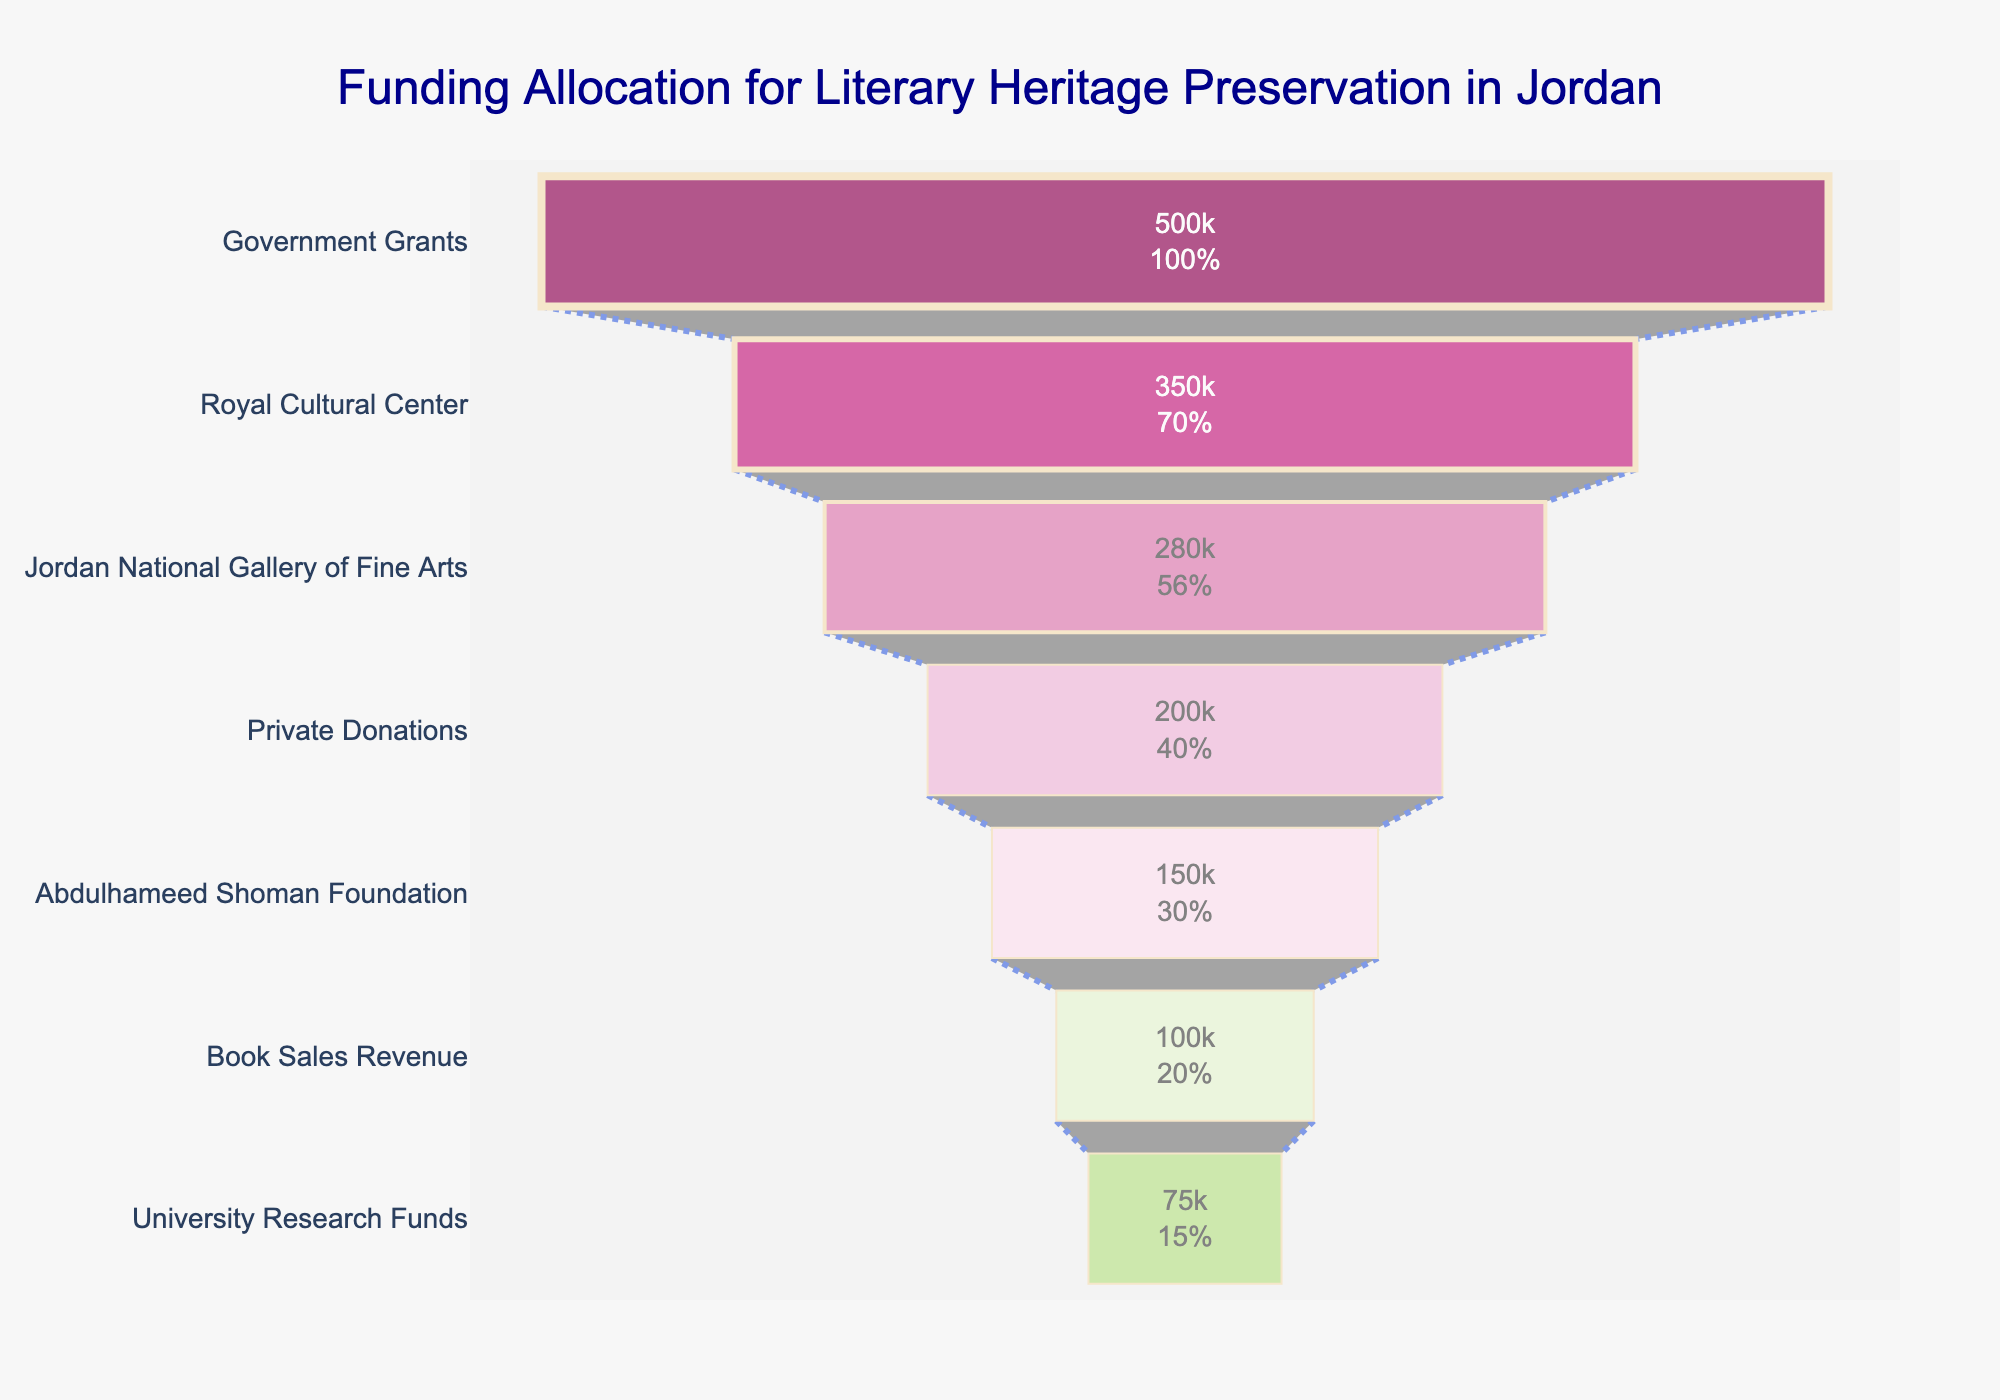How much funding did the Royal Cultural Center receive? Look at the funnel chart and identify the stage labeled as "Royal Cultural Center." The value inside the bar is the amount of funding received by this center.
Answer: 350,000 JOD Which stage has the highest funding allocation? Identify the bar with the longest length at the top of the funnel chart. This corresponds to the stage with the highest funding allocation.
Answer: Government Grants How does the funding from Private Donations compare to Book Sales Revenue? Locate the bars labeled "Private Donations" and "Book Sales Revenue" on the funnel chart. Compare the lengths and values to determine which is larger and by how much.
Answer: Private Donations are 100,000 JOD more than Book Sales Revenue What is the total amount of funding coming from Jordan National Gallery of Fine Arts and Abdulhameed Shoman Foundation? Sum the funding amounts of the respective stages. Jordan National Gallery of Fine Arts received 280,000 JOD and Abdulhameed Shoman Foundation received 150,000 JOD. 280,000 + 150,000 = 430,000 JOD.
Answer: 430,000 JOD What percentage of the total funding does the Government Grants stage contribute? Sum all the funding amounts to find the total funding. Then, divide the Government Grants amount (500,000 JOD) by the total and multiply by 100 to find the percentage.
Answer: 500,000 / 1,655,000 ≈ 30.21% Which two stages combined have the smallest funding amount, and what is their total? Identify the two stages with the smallest values on the chart, which are Book Sales Revenue (100,000 JOD) and University Research Funds (75,000 JOD). Sum these amounts. 100,000 + 75,000 = 175,000 JOD.
Answer: Book Sales Revenue and University Research Funds, 175,000 JOD If we exclude the Government Grants, what is the average funding allocated across the remaining stages? Exclude the highest value (Government Grants) from the total funding. Sum the amounts of the remaining stages: 1,155,000 JOD. Divide this total by the number of remaining stages (6).
Answer: 1,155,000 / 6 ≈ 192,500 JOD Which source contributes more funding, the Abdulhameed Shoman Foundation or University Research Funds? Compare the lengths and values of the bars labeled "Abdulhameed Shoman Foundation" and "University Research Funds."
Answer: Abdulhameed Shoman Foundation 